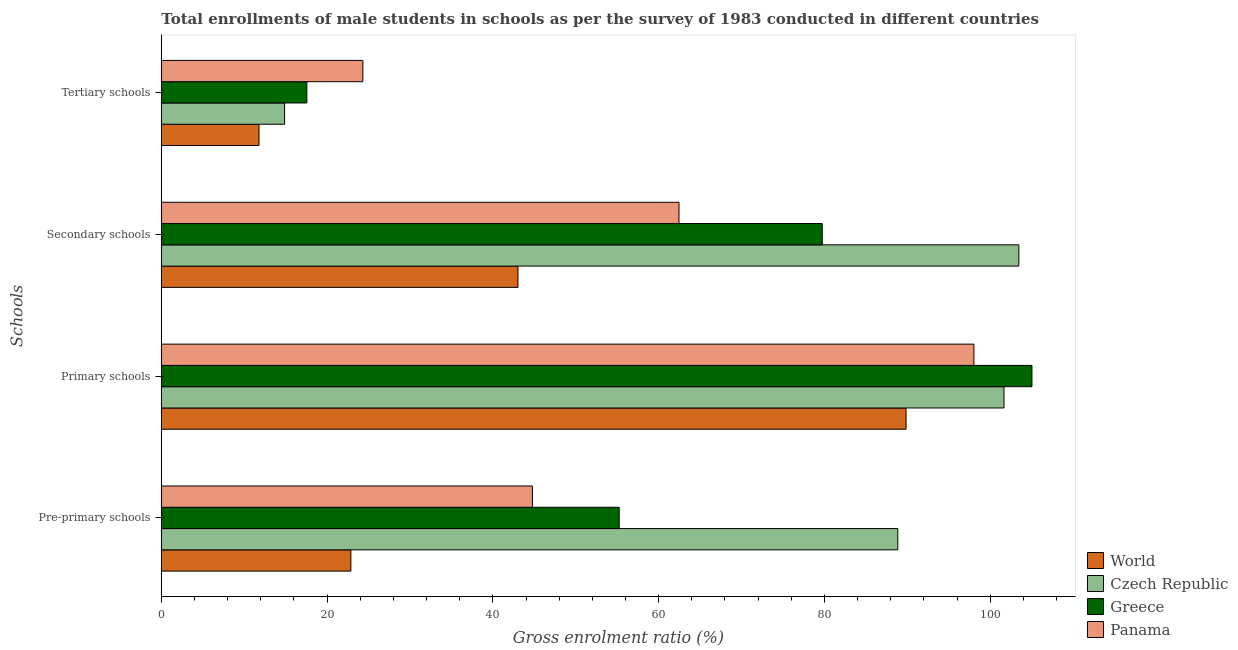How many different coloured bars are there?
Your response must be concise. 4. How many bars are there on the 3rd tick from the top?
Ensure brevity in your answer.  4. What is the label of the 4th group of bars from the top?
Provide a short and direct response. Pre-primary schools. What is the gross enrolment ratio(male) in pre-primary schools in Greece?
Provide a short and direct response. 55.24. Across all countries, what is the maximum gross enrolment ratio(male) in primary schools?
Offer a terse response. 105.03. Across all countries, what is the minimum gross enrolment ratio(male) in secondary schools?
Provide a short and direct response. 43.03. In which country was the gross enrolment ratio(male) in secondary schools maximum?
Make the answer very short. Czech Republic. In which country was the gross enrolment ratio(male) in pre-primary schools minimum?
Offer a very short reply. World. What is the total gross enrolment ratio(male) in tertiary schools in the graph?
Your answer should be compact. 68.53. What is the difference between the gross enrolment ratio(male) in primary schools in Panama and that in World?
Keep it short and to the point. 8.18. What is the difference between the gross enrolment ratio(male) in secondary schools in Czech Republic and the gross enrolment ratio(male) in tertiary schools in Greece?
Make the answer very short. 85.9. What is the average gross enrolment ratio(male) in tertiary schools per country?
Give a very brief answer. 17.13. What is the difference between the gross enrolment ratio(male) in tertiary schools and gross enrolment ratio(male) in primary schools in Czech Republic?
Provide a short and direct response. -86.79. What is the ratio of the gross enrolment ratio(male) in primary schools in World to that in Panama?
Keep it short and to the point. 0.92. Is the difference between the gross enrolment ratio(male) in pre-primary schools in Czech Republic and Greece greater than the difference between the gross enrolment ratio(male) in secondary schools in Czech Republic and Greece?
Your answer should be very brief. Yes. What is the difference between the highest and the second highest gross enrolment ratio(male) in primary schools?
Your answer should be compact. 3.37. What is the difference between the highest and the lowest gross enrolment ratio(male) in secondary schools?
Make the answer very short. 60.43. In how many countries, is the gross enrolment ratio(male) in tertiary schools greater than the average gross enrolment ratio(male) in tertiary schools taken over all countries?
Offer a terse response. 2. Is the sum of the gross enrolment ratio(male) in secondary schools in Czech Republic and Greece greater than the maximum gross enrolment ratio(male) in primary schools across all countries?
Your response must be concise. Yes. What does the 3rd bar from the top in Tertiary schools represents?
Provide a short and direct response. Czech Republic. What does the 2nd bar from the bottom in Tertiary schools represents?
Keep it short and to the point. Czech Republic. Are all the bars in the graph horizontal?
Your answer should be compact. Yes. How many countries are there in the graph?
Provide a succinct answer. 4. What is the difference between two consecutive major ticks on the X-axis?
Ensure brevity in your answer.  20. Does the graph contain any zero values?
Your answer should be compact. No. What is the title of the graph?
Provide a short and direct response. Total enrollments of male students in schools as per the survey of 1983 conducted in different countries. Does "Morocco" appear as one of the legend labels in the graph?
Give a very brief answer. No. What is the label or title of the X-axis?
Ensure brevity in your answer.  Gross enrolment ratio (%). What is the label or title of the Y-axis?
Your answer should be very brief. Schools. What is the Gross enrolment ratio (%) of World in Pre-primary schools?
Your answer should be compact. 22.87. What is the Gross enrolment ratio (%) of Czech Republic in Pre-primary schools?
Make the answer very short. 88.85. What is the Gross enrolment ratio (%) of Greece in Pre-primary schools?
Your response must be concise. 55.24. What is the Gross enrolment ratio (%) in Panama in Pre-primary schools?
Offer a very short reply. 44.77. What is the Gross enrolment ratio (%) of World in Primary schools?
Your answer should be very brief. 89.85. What is the Gross enrolment ratio (%) in Czech Republic in Primary schools?
Offer a very short reply. 101.66. What is the Gross enrolment ratio (%) of Greece in Primary schools?
Make the answer very short. 105.03. What is the Gross enrolment ratio (%) of Panama in Primary schools?
Offer a very short reply. 98.03. What is the Gross enrolment ratio (%) of World in Secondary schools?
Your answer should be compact. 43.03. What is the Gross enrolment ratio (%) in Czech Republic in Secondary schools?
Provide a short and direct response. 103.45. What is the Gross enrolment ratio (%) in Greece in Secondary schools?
Make the answer very short. 79.74. What is the Gross enrolment ratio (%) of Panama in Secondary schools?
Ensure brevity in your answer.  62.45. What is the Gross enrolment ratio (%) in World in Tertiary schools?
Give a very brief answer. 11.78. What is the Gross enrolment ratio (%) of Czech Republic in Tertiary schools?
Your response must be concise. 14.87. What is the Gross enrolment ratio (%) of Greece in Tertiary schools?
Offer a terse response. 17.56. What is the Gross enrolment ratio (%) in Panama in Tertiary schools?
Give a very brief answer. 24.32. Across all Schools, what is the maximum Gross enrolment ratio (%) in World?
Make the answer very short. 89.85. Across all Schools, what is the maximum Gross enrolment ratio (%) of Czech Republic?
Your response must be concise. 103.45. Across all Schools, what is the maximum Gross enrolment ratio (%) in Greece?
Your answer should be very brief. 105.03. Across all Schools, what is the maximum Gross enrolment ratio (%) in Panama?
Make the answer very short. 98.03. Across all Schools, what is the minimum Gross enrolment ratio (%) of World?
Your answer should be very brief. 11.78. Across all Schools, what is the minimum Gross enrolment ratio (%) in Czech Republic?
Ensure brevity in your answer.  14.87. Across all Schools, what is the minimum Gross enrolment ratio (%) of Greece?
Keep it short and to the point. 17.56. Across all Schools, what is the minimum Gross enrolment ratio (%) of Panama?
Keep it short and to the point. 24.32. What is the total Gross enrolment ratio (%) of World in the graph?
Keep it short and to the point. 167.52. What is the total Gross enrolment ratio (%) of Czech Republic in the graph?
Offer a very short reply. 308.84. What is the total Gross enrolment ratio (%) in Greece in the graph?
Give a very brief answer. 257.57. What is the total Gross enrolment ratio (%) of Panama in the graph?
Provide a succinct answer. 229.57. What is the difference between the Gross enrolment ratio (%) of World in Pre-primary schools and that in Primary schools?
Keep it short and to the point. -66.98. What is the difference between the Gross enrolment ratio (%) of Czech Republic in Pre-primary schools and that in Primary schools?
Give a very brief answer. -12.81. What is the difference between the Gross enrolment ratio (%) in Greece in Pre-primary schools and that in Primary schools?
Your answer should be very brief. -49.79. What is the difference between the Gross enrolment ratio (%) of Panama in Pre-primary schools and that in Primary schools?
Make the answer very short. -53.26. What is the difference between the Gross enrolment ratio (%) of World in Pre-primary schools and that in Secondary schools?
Offer a terse response. -20.16. What is the difference between the Gross enrolment ratio (%) in Czech Republic in Pre-primary schools and that in Secondary schools?
Your answer should be compact. -14.6. What is the difference between the Gross enrolment ratio (%) of Greece in Pre-primary schools and that in Secondary schools?
Your response must be concise. -24.5. What is the difference between the Gross enrolment ratio (%) of Panama in Pre-primary schools and that in Secondary schools?
Provide a short and direct response. -17.68. What is the difference between the Gross enrolment ratio (%) of World in Pre-primary schools and that in Tertiary schools?
Your answer should be compact. 11.08. What is the difference between the Gross enrolment ratio (%) of Czech Republic in Pre-primary schools and that in Tertiary schools?
Keep it short and to the point. 73.98. What is the difference between the Gross enrolment ratio (%) of Greece in Pre-primary schools and that in Tertiary schools?
Provide a succinct answer. 37.68. What is the difference between the Gross enrolment ratio (%) in Panama in Pre-primary schools and that in Tertiary schools?
Make the answer very short. 20.45. What is the difference between the Gross enrolment ratio (%) of World in Primary schools and that in Secondary schools?
Your answer should be very brief. 46.82. What is the difference between the Gross enrolment ratio (%) of Czech Republic in Primary schools and that in Secondary schools?
Give a very brief answer. -1.79. What is the difference between the Gross enrolment ratio (%) of Greece in Primary schools and that in Secondary schools?
Provide a short and direct response. 25.29. What is the difference between the Gross enrolment ratio (%) in Panama in Primary schools and that in Secondary schools?
Provide a succinct answer. 35.58. What is the difference between the Gross enrolment ratio (%) of World in Primary schools and that in Tertiary schools?
Your answer should be very brief. 78.06. What is the difference between the Gross enrolment ratio (%) of Czech Republic in Primary schools and that in Tertiary schools?
Offer a terse response. 86.79. What is the difference between the Gross enrolment ratio (%) of Greece in Primary schools and that in Tertiary schools?
Your answer should be very brief. 87.47. What is the difference between the Gross enrolment ratio (%) in Panama in Primary schools and that in Tertiary schools?
Ensure brevity in your answer.  73.71. What is the difference between the Gross enrolment ratio (%) in World in Secondary schools and that in Tertiary schools?
Give a very brief answer. 31.24. What is the difference between the Gross enrolment ratio (%) in Czech Republic in Secondary schools and that in Tertiary schools?
Your answer should be very brief. 88.58. What is the difference between the Gross enrolment ratio (%) of Greece in Secondary schools and that in Tertiary schools?
Your answer should be compact. 62.18. What is the difference between the Gross enrolment ratio (%) of Panama in Secondary schools and that in Tertiary schools?
Provide a short and direct response. 38.13. What is the difference between the Gross enrolment ratio (%) of World in Pre-primary schools and the Gross enrolment ratio (%) of Czech Republic in Primary schools?
Provide a succinct answer. -78.8. What is the difference between the Gross enrolment ratio (%) of World in Pre-primary schools and the Gross enrolment ratio (%) of Greece in Primary schools?
Make the answer very short. -82.17. What is the difference between the Gross enrolment ratio (%) in World in Pre-primary schools and the Gross enrolment ratio (%) in Panama in Primary schools?
Keep it short and to the point. -75.16. What is the difference between the Gross enrolment ratio (%) in Czech Republic in Pre-primary schools and the Gross enrolment ratio (%) in Greece in Primary schools?
Give a very brief answer. -16.18. What is the difference between the Gross enrolment ratio (%) of Czech Republic in Pre-primary schools and the Gross enrolment ratio (%) of Panama in Primary schools?
Keep it short and to the point. -9.18. What is the difference between the Gross enrolment ratio (%) in Greece in Pre-primary schools and the Gross enrolment ratio (%) in Panama in Primary schools?
Provide a short and direct response. -42.79. What is the difference between the Gross enrolment ratio (%) of World in Pre-primary schools and the Gross enrolment ratio (%) of Czech Republic in Secondary schools?
Your answer should be very brief. -80.59. What is the difference between the Gross enrolment ratio (%) of World in Pre-primary schools and the Gross enrolment ratio (%) of Greece in Secondary schools?
Offer a very short reply. -56.87. What is the difference between the Gross enrolment ratio (%) of World in Pre-primary schools and the Gross enrolment ratio (%) of Panama in Secondary schools?
Keep it short and to the point. -39.58. What is the difference between the Gross enrolment ratio (%) in Czech Republic in Pre-primary schools and the Gross enrolment ratio (%) in Greece in Secondary schools?
Keep it short and to the point. 9.11. What is the difference between the Gross enrolment ratio (%) of Czech Republic in Pre-primary schools and the Gross enrolment ratio (%) of Panama in Secondary schools?
Provide a short and direct response. 26.4. What is the difference between the Gross enrolment ratio (%) in Greece in Pre-primary schools and the Gross enrolment ratio (%) in Panama in Secondary schools?
Offer a very short reply. -7.21. What is the difference between the Gross enrolment ratio (%) of World in Pre-primary schools and the Gross enrolment ratio (%) of Czech Republic in Tertiary schools?
Your answer should be compact. 7.99. What is the difference between the Gross enrolment ratio (%) of World in Pre-primary schools and the Gross enrolment ratio (%) of Greece in Tertiary schools?
Offer a terse response. 5.31. What is the difference between the Gross enrolment ratio (%) in World in Pre-primary schools and the Gross enrolment ratio (%) in Panama in Tertiary schools?
Provide a succinct answer. -1.45. What is the difference between the Gross enrolment ratio (%) of Czech Republic in Pre-primary schools and the Gross enrolment ratio (%) of Greece in Tertiary schools?
Offer a terse response. 71.29. What is the difference between the Gross enrolment ratio (%) in Czech Republic in Pre-primary schools and the Gross enrolment ratio (%) in Panama in Tertiary schools?
Your answer should be compact. 64.53. What is the difference between the Gross enrolment ratio (%) in Greece in Pre-primary schools and the Gross enrolment ratio (%) in Panama in Tertiary schools?
Keep it short and to the point. 30.92. What is the difference between the Gross enrolment ratio (%) in World in Primary schools and the Gross enrolment ratio (%) in Czech Republic in Secondary schools?
Your answer should be very brief. -13.61. What is the difference between the Gross enrolment ratio (%) in World in Primary schools and the Gross enrolment ratio (%) in Greece in Secondary schools?
Provide a succinct answer. 10.11. What is the difference between the Gross enrolment ratio (%) of World in Primary schools and the Gross enrolment ratio (%) of Panama in Secondary schools?
Offer a terse response. 27.4. What is the difference between the Gross enrolment ratio (%) of Czech Republic in Primary schools and the Gross enrolment ratio (%) of Greece in Secondary schools?
Provide a succinct answer. 21.92. What is the difference between the Gross enrolment ratio (%) of Czech Republic in Primary schools and the Gross enrolment ratio (%) of Panama in Secondary schools?
Ensure brevity in your answer.  39.21. What is the difference between the Gross enrolment ratio (%) in Greece in Primary schools and the Gross enrolment ratio (%) in Panama in Secondary schools?
Give a very brief answer. 42.58. What is the difference between the Gross enrolment ratio (%) in World in Primary schools and the Gross enrolment ratio (%) in Czech Republic in Tertiary schools?
Ensure brevity in your answer.  74.97. What is the difference between the Gross enrolment ratio (%) in World in Primary schools and the Gross enrolment ratio (%) in Greece in Tertiary schools?
Ensure brevity in your answer.  72.29. What is the difference between the Gross enrolment ratio (%) of World in Primary schools and the Gross enrolment ratio (%) of Panama in Tertiary schools?
Offer a very short reply. 65.53. What is the difference between the Gross enrolment ratio (%) of Czech Republic in Primary schools and the Gross enrolment ratio (%) of Greece in Tertiary schools?
Provide a short and direct response. 84.1. What is the difference between the Gross enrolment ratio (%) in Czech Republic in Primary schools and the Gross enrolment ratio (%) in Panama in Tertiary schools?
Give a very brief answer. 77.35. What is the difference between the Gross enrolment ratio (%) of Greece in Primary schools and the Gross enrolment ratio (%) of Panama in Tertiary schools?
Your response must be concise. 80.71. What is the difference between the Gross enrolment ratio (%) of World in Secondary schools and the Gross enrolment ratio (%) of Czech Republic in Tertiary schools?
Your answer should be very brief. 28.15. What is the difference between the Gross enrolment ratio (%) in World in Secondary schools and the Gross enrolment ratio (%) in Greece in Tertiary schools?
Your answer should be very brief. 25.47. What is the difference between the Gross enrolment ratio (%) of World in Secondary schools and the Gross enrolment ratio (%) of Panama in Tertiary schools?
Give a very brief answer. 18.71. What is the difference between the Gross enrolment ratio (%) in Czech Republic in Secondary schools and the Gross enrolment ratio (%) in Greece in Tertiary schools?
Your answer should be compact. 85.9. What is the difference between the Gross enrolment ratio (%) in Czech Republic in Secondary schools and the Gross enrolment ratio (%) in Panama in Tertiary schools?
Provide a succinct answer. 79.14. What is the difference between the Gross enrolment ratio (%) of Greece in Secondary schools and the Gross enrolment ratio (%) of Panama in Tertiary schools?
Offer a terse response. 55.42. What is the average Gross enrolment ratio (%) of World per Schools?
Offer a very short reply. 41.88. What is the average Gross enrolment ratio (%) of Czech Republic per Schools?
Your answer should be very brief. 77.21. What is the average Gross enrolment ratio (%) of Greece per Schools?
Offer a very short reply. 64.39. What is the average Gross enrolment ratio (%) in Panama per Schools?
Offer a terse response. 57.39. What is the difference between the Gross enrolment ratio (%) of World and Gross enrolment ratio (%) of Czech Republic in Pre-primary schools?
Provide a succinct answer. -65.98. What is the difference between the Gross enrolment ratio (%) of World and Gross enrolment ratio (%) of Greece in Pre-primary schools?
Your answer should be very brief. -32.37. What is the difference between the Gross enrolment ratio (%) in World and Gross enrolment ratio (%) in Panama in Pre-primary schools?
Your response must be concise. -21.9. What is the difference between the Gross enrolment ratio (%) of Czech Republic and Gross enrolment ratio (%) of Greece in Pre-primary schools?
Offer a terse response. 33.61. What is the difference between the Gross enrolment ratio (%) in Czech Republic and Gross enrolment ratio (%) in Panama in Pre-primary schools?
Provide a short and direct response. 44.08. What is the difference between the Gross enrolment ratio (%) in Greece and Gross enrolment ratio (%) in Panama in Pre-primary schools?
Provide a succinct answer. 10.47. What is the difference between the Gross enrolment ratio (%) in World and Gross enrolment ratio (%) in Czech Republic in Primary schools?
Your response must be concise. -11.82. What is the difference between the Gross enrolment ratio (%) of World and Gross enrolment ratio (%) of Greece in Primary schools?
Provide a succinct answer. -15.18. What is the difference between the Gross enrolment ratio (%) in World and Gross enrolment ratio (%) in Panama in Primary schools?
Your response must be concise. -8.18. What is the difference between the Gross enrolment ratio (%) of Czech Republic and Gross enrolment ratio (%) of Greece in Primary schools?
Offer a very short reply. -3.37. What is the difference between the Gross enrolment ratio (%) of Czech Republic and Gross enrolment ratio (%) of Panama in Primary schools?
Make the answer very short. 3.63. What is the difference between the Gross enrolment ratio (%) in Greece and Gross enrolment ratio (%) in Panama in Primary schools?
Ensure brevity in your answer.  7. What is the difference between the Gross enrolment ratio (%) of World and Gross enrolment ratio (%) of Czech Republic in Secondary schools?
Offer a terse response. -60.43. What is the difference between the Gross enrolment ratio (%) of World and Gross enrolment ratio (%) of Greece in Secondary schools?
Offer a very short reply. -36.71. What is the difference between the Gross enrolment ratio (%) in World and Gross enrolment ratio (%) in Panama in Secondary schools?
Offer a terse response. -19.43. What is the difference between the Gross enrolment ratio (%) of Czech Republic and Gross enrolment ratio (%) of Greece in Secondary schools?
Ensure brevity in your answer.  23.72. What is the difference between the Gross enrolment ratio (%) of Czech Republic and Gross enrolment ratio (%) of Panama in Secondary schools?
Keep it short and to the point. 41. What is the difference between the Gross enrolment ratio (%) of Greece and Gross enrolment ratio (%) of Panama in Secondary schools?
Your response must be concise. 17.29. What is the difference between the Gross enrolment ratio (%) in World and Gross enrolment ratio (%) in Czech Republic in Tertiary schools?
Offer a very short reply. -3.09. What is the difference between the Gross enrolment ratio (%) of World and Gross enrolment ratio (%) of Greece in Tertiary schools?
Your answer should be compact. -5.77. What is the difference between the Gross enrolment ratio (%) in World and Gross enrolment ratio (%) in Panama in Tertiary schools?
Keep it short and to the point. -12.53. What is the difference between the Gross enrolment ratio (%) in Czech Republic and Gross enrolment ratio (%) in Greece in Tertiary schools?
Your response must be concise. -2.69. What is the difference between the Gross enrolment ratio (%) of Czech Republic and Gross enrolment ratio (%) of Panama in Tertiary schools?
Your answer should be very brief. -9.44. What is the difference between the Gross enrolment ratio (%) of Greece and Gross enrolment ratio (%) of Panama in Tertiary schools?
Provide a short and direct response. -6.76. What is the ratio of the Gross enrolment ratio (%) of World in Pre-primary schools to that in Primary schools?
Provide a short and direct response. 0.25. What is the ratio of the Gross enrolment ratio (%) of Czech Republic in Pre-primary schools to that in Primary schools?
Make the answer very short. 0.87. What is the ratio of the Gross enrolment ratio (%) in Greece in Pre-primary schools to that in Primary schools?
Your answer should be very brief. 0.53. What is the ratio of the Gross enrolment ratio (%) of Panama in Pre-primary schools to that in Primary schools?
Offer a terse response. 0.46. What is the ratio of the Gross enrolment ratio (%) in World in Pre-primary schools to that in Secondary schools?
Your answer should be compact. 0.53. What is the ratio of the Gross enrolment ratio (%) of Czech Republic in Pre-primary schools to that in Secondary schools?
Your answer should be compact. 0.86. What is the ratio of the Gross enrolment ratio (%) of Greece in Pre-primary schools to that in Secondary schools?
Make the answer very short. 0.69. What is the ratio of the Gross enrolment ratio (%) in Panama in Pre-primary schools to that in Secondary schools?
Ensure brevity in your answer.  0.72. What is the ratio of the Gross enrolment ratio (%) of World in Pre-primary schools to that in Tertiary schools?
Your answer should be compact. 1.94. What is the ratio of the Gross enrolment ratio (%) of Czech Republic in Pre-primary schools to that in Tertiary schools?
Offer a terse response. 5.97. What is the ratio of the Gross enrolment ratio (%) of Greece in Pre-primary schools to that in Tertiary schools?
Your answer should be compact. 3.15. What is the ratio of the Gross enrolment ratio (%) in Panama in Pre-primary schools to that in Tertiary schools?
Provide a succinct answer. 1.84. What is the ratio of the Gross enrolment ratio (%) of World in Primary schools to that in Secondary schools?
Offer a very short reply. 2.09. What is the ratio of the Gross enrolment ratio (%) of Czech Republic in Primary schools to that in Secondary schools?
Your response must be concise. 0.98. What is the ratio of the Gross enrolment ratio (%) in Greece in Primary schools to that in Secondary schools?
Your answer should be compact. 1.32. What is the ratio of the Gross enrolment ratio (%) of Panama in Primary schools to that in Secondary schools?
Your answer should be very brief. 1.57. What is the ratio of the Gross enrolment ratio (%) of World in Primary schools to that in Tertiary schools?
Offer a very short reply. 7.62. What is the ratio of the Gross enrolment ratio (%) of Czech Republic in Primary schools to that in Tertiary schools?
Your response must be concise. 6.84. What is the ratio of the Gross enrolment ratio (%) in Greece in Primary schools to that in Tertiary schools?
Provide a short and direct response. 5.98. What is the ratio of the Gross enrolment ratio (%) of Panama in Primary schools to that in Tertiary schools?
Provide a short and direct response. 4.03. What is the ratio of the Gross enrolment ratio (%) in World in Secondary schools to that in Tertiary schools?
Ensure brevity in your answer.  3.65. What is the ratio of the Gross enrolment ratio (%) of Czech Republic in Secondary schools to that in Tertiary schools?
Your answer should be compact. 6.96. What is the ratio of the Gross enrolment ratio (%) in Greece in Secondary schools to that in Tertiary schools?
Offer a very short reply. 4.54. What is the ratio of the Gross enrolment ratio (%) of Panama in Secondary schools to that in Tertiary schools?
Offer a terse response. 2.57. What is the difference between the highest and the second highest Gross enrolment ratio (%) in World?
Your answer should be compact. 46.82. What is the difference between the highest and the second highest Gross enrolment ratio (%) of Czech Republic?
Provide a succinct answer. 1.79. What is the difference between the highest and the second highest Gross enrolment ratio (%) in Greece?
Your answer should be compact. 25.29. What is the difference between the highest and the second highest Gross enrolment ratio (%) of Panama?
Provide a succinct answer. 35.58. What is the difference between the highest and the lowest Gross enrolment ratio (%) of World?
Your answer should be compact. 78.06. What is the difference between the highest and the lowest Gross enrolment ratio (%) of Czech Republic?
Your answer should be very brief. 88.58. What is the difference between the highest and the lowest Gross enrolment ratio (%) in Greece?
Your answer should be compact. 87.47. What is the difference between the highest and the lowest Gross enrolment ratio (%) of Panama?
Provide a short and direct response. 73.71. 